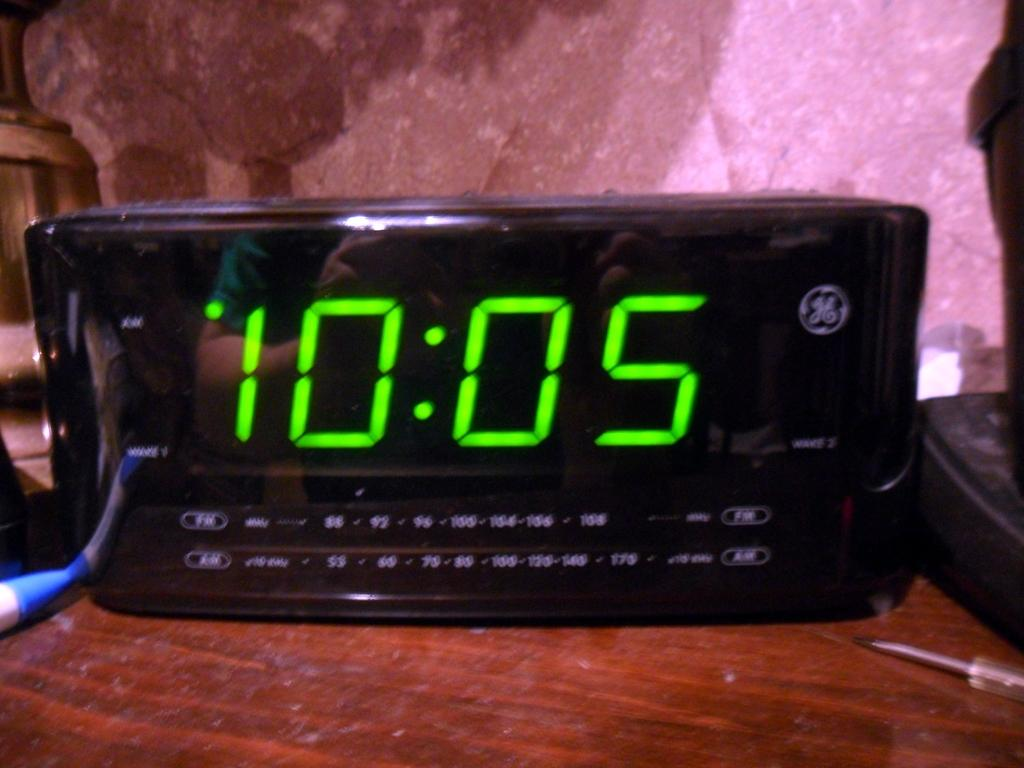<image>
Provide a brief description of the given image. An alarm clock says 10:05 in green LEDs. 